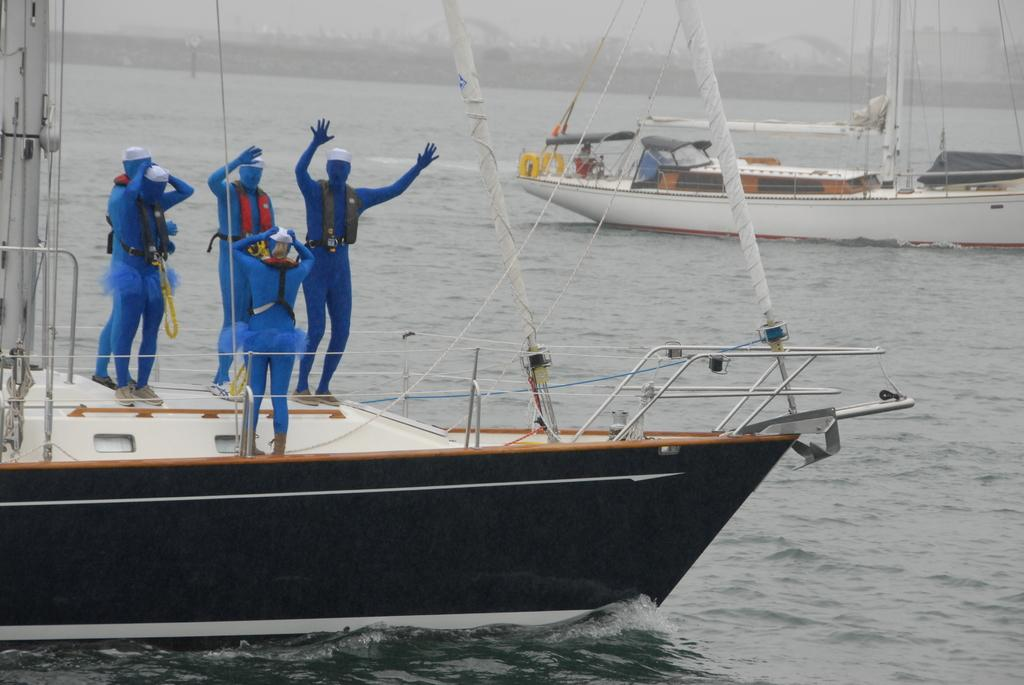What is the main subject of the image? The main subject of the image is persons standing on a ship. Can you describe the surrounding environment in the image? There are other ships visible in the image, and there is water and sky visible as well. What type of corn can be seen growing on the boat in the image? There is no corn or boat present in the image; it features persons standing on a ship in water with other ships visible. What is being served for breakfast on the ship in the image? There is no information about breakfast or any food being served in the image. 